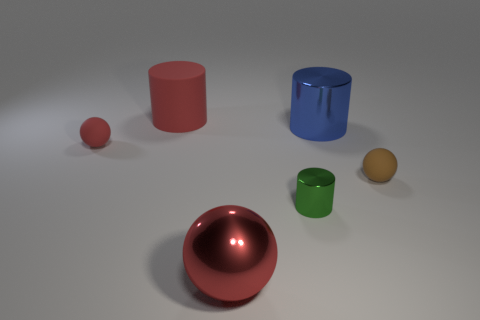The blue object that is made of the same material as the tiny green cylinder is what size?
Your answer should be compact. Large. Are there fewer red metal spheres than purple metal objects?
Your answer should be compact. No. How many big objects are either brown things or green objects?
Make the answer very short. 0. What number of things are on the left side of the big blue cylinder and to the right of the large red matte thing?
Your response must be concise. 2. Are there more big purple metal balls than big things?
Provide a succinct answer. No. Is the large matte cylinder the same color as the tiny metallic cylinder?
Provide a succinct answer. No. What is the cylinder that is behind the tiny green cylinder and right of the shiny ball made of?
Offer a terse response. Metal. The blue metal cylinder has what size?
Offer a terse response. Large. What number of small balls are right of the big metal thing that is in front of the big cylinder that is to the right of the big red metal sphere?
Keep it short and to the point. 1. There is a big thing that is in front of the small matte thing that is on the left side of the brown matte thing; what shape is it?
Offer a very short reply. Sphere. 